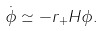<formula> <loc_0><loc_0><loc_500><loc_500>\dot { \phi } \simeq - r _ { + } H \phi .</formula> 